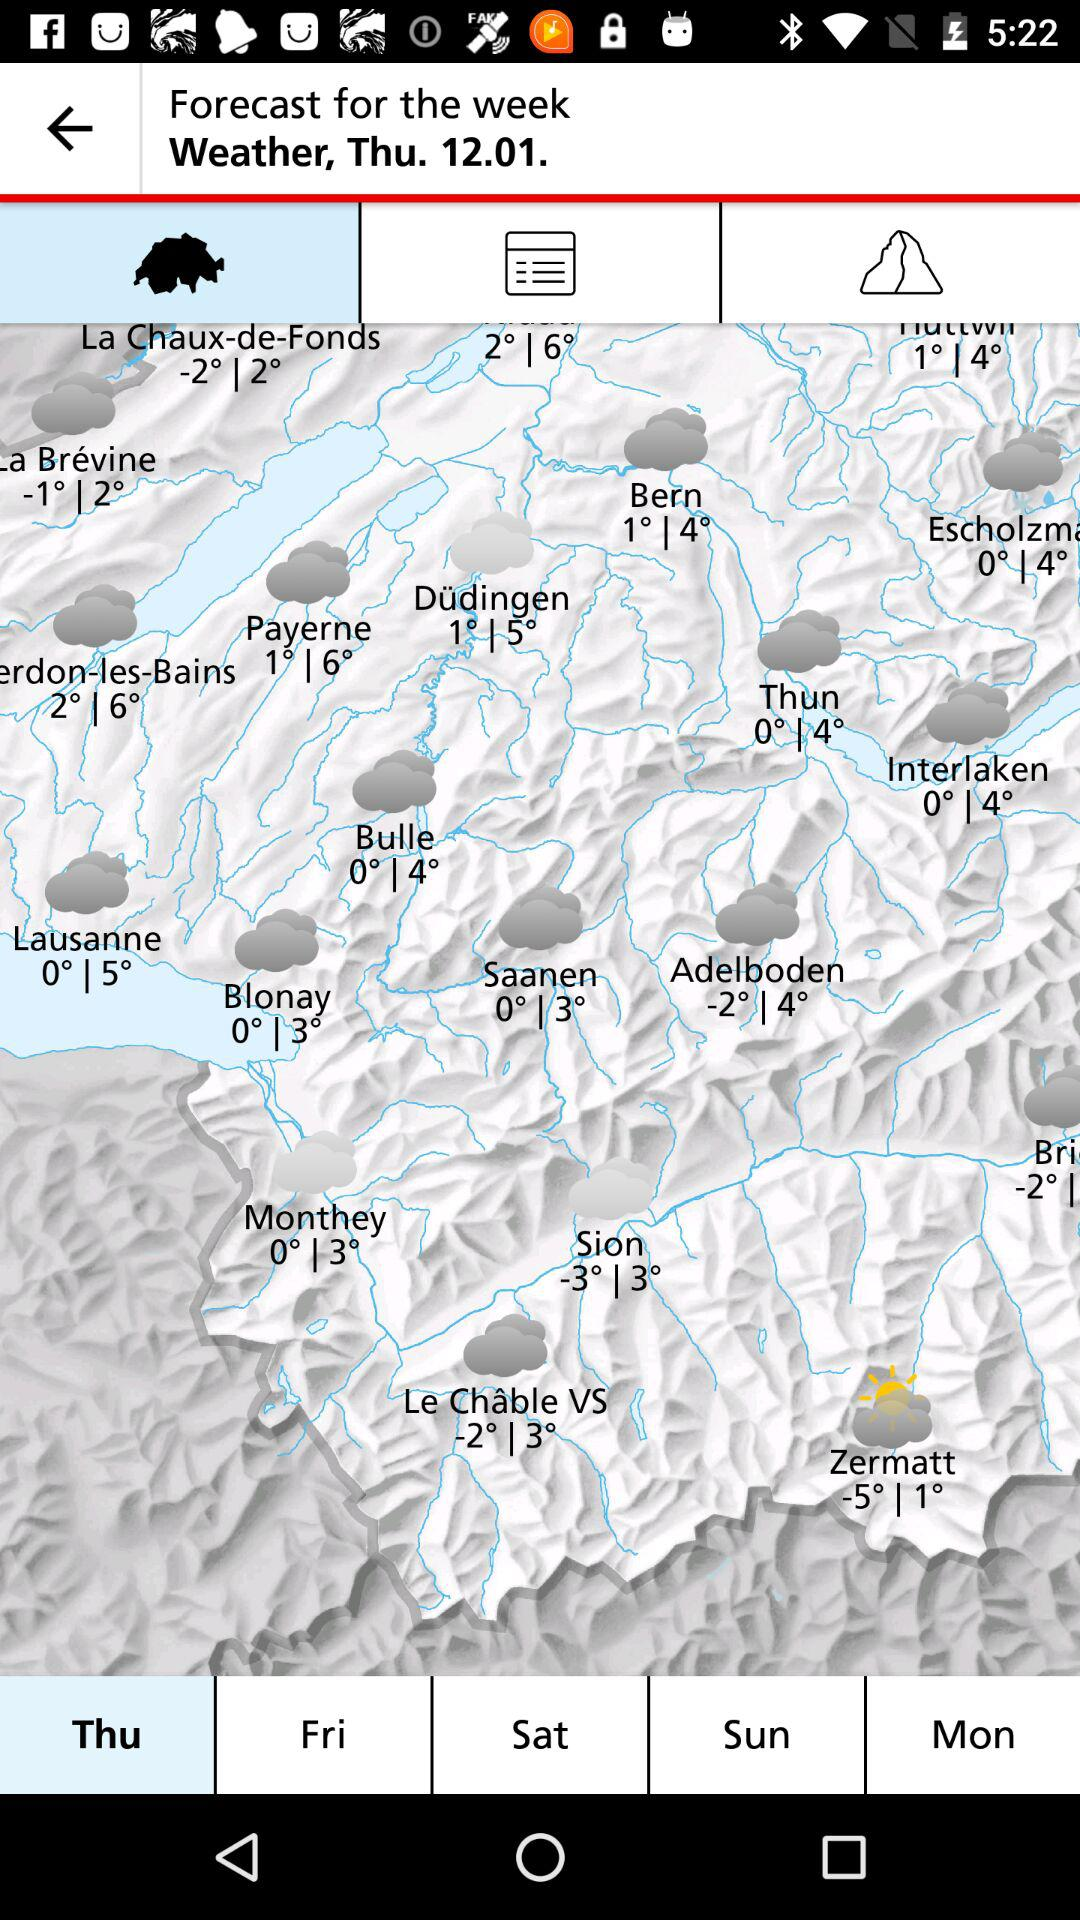Which day is selected? The selected day is Thursday. 